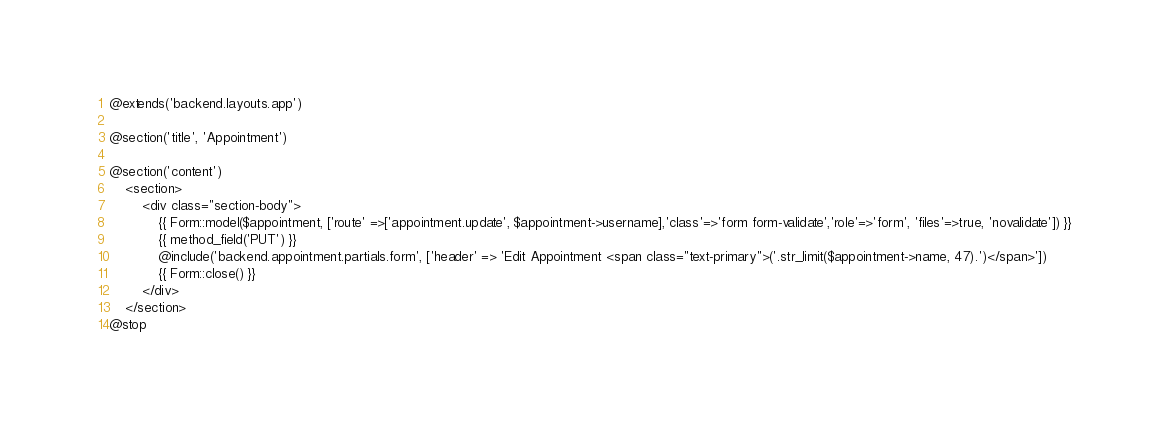Convert code to text. <code><loc_0><loc_0><loc_500><loc_500><_PHP_>@extends('backend.layouts.app')

@section('title', 'Appointment')

@section('content')
    <section>
        <div class="section-body">
            {{ Form::model($appointment, ['route' =>['appointment.update', $appointment->username],'class'=>'form form-validate','role'=>'form', 'files'=>true, 'novalidate']) }}
            {{ method_field('PUT') }}
            @include('backend.appointment.partials.form', ['header' => 'Edit Appointment <span class="text-primary">('.str_limit($appointment->name, 47).')</span>'])
            {{ Form::close() }}
        </div>
    </section>
@stop</code> 